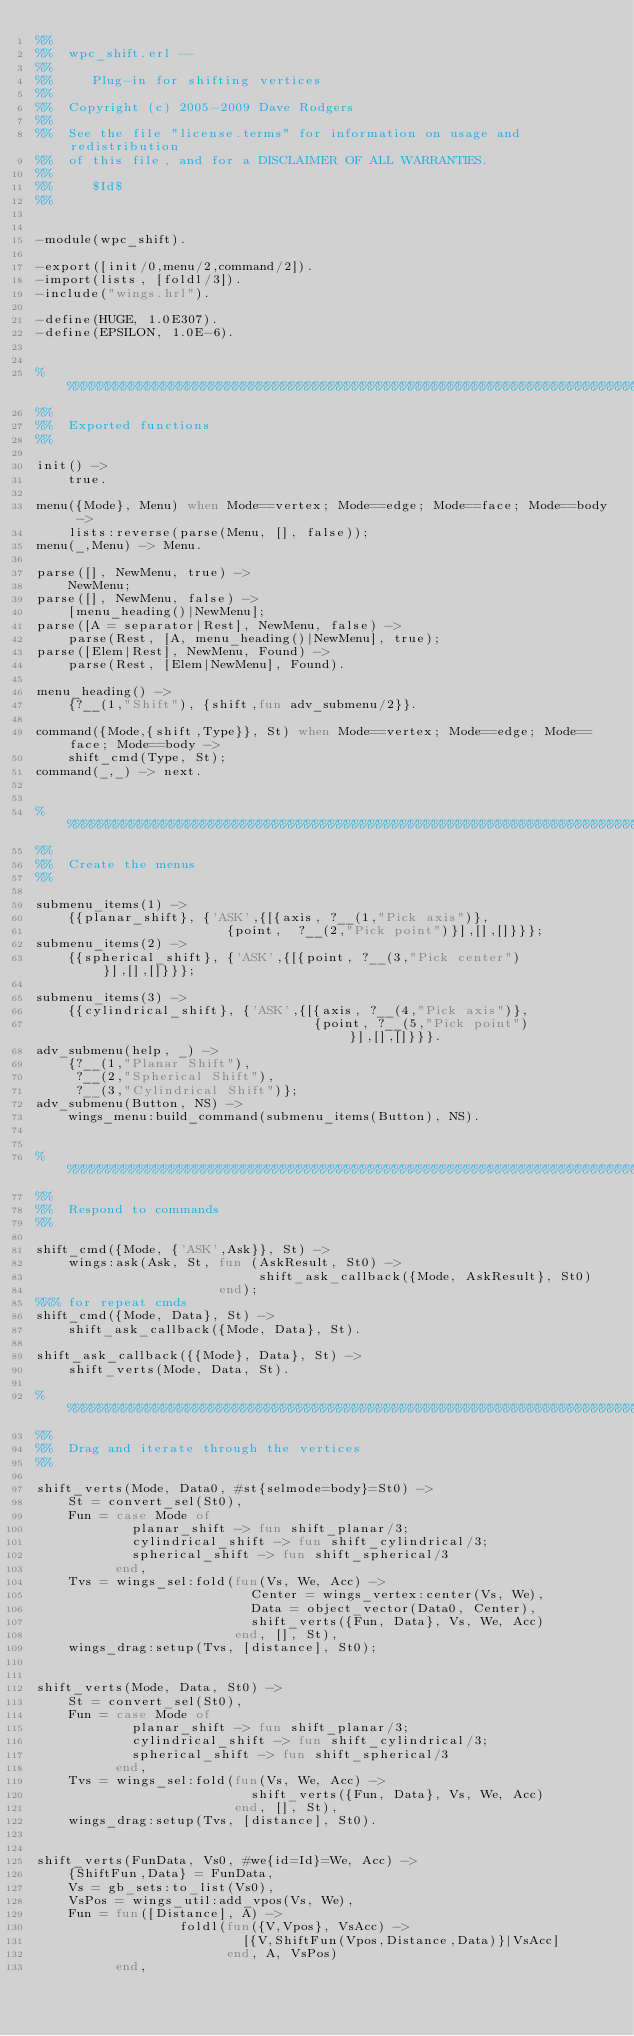Convert code to text. <code><loc_0><loc_0><loc_500><loc_500><_Erlang_>%%
%%  wpc_shift.erl --
%%
%%     Plug-in for shifting vertices
%%
%%  Copyright (c) 2005-2009 Dave Rodgers
%%
%%  See the file "license.terms" for information on usage and redistribution
%%  of this file, and for a DISCLAIMER OF ALL WARRANTIES.
%%
%%     $Id$
%%


-module(wpc_shift).

-export([init/0,menu/2,command/2]).
-import(lists, [foldl/3]).
-include("wings.hrl").

-define(HUGE, 1.0E307).
-define(EPSILON, 1.0E-6).


%%%%%%%%%%%%%%%%%%%%%%%%%%%%%%%%%%%%%%%%%%%%%%%%%%%%%%%%%%%%%%%%%%%%%%%%%%%%%%%%%
%%
%%  Exported functions
%%

init() ->
    true.

menu({Mode}, Menu) when Mode==vertex; Mode==edge; Mode==face; Mode==body ->
    lists:reverse(parse(Menu, [], false));
menu(_,Menu) -> Menu.

parse([], NewMenu, true) ->
    NewMenu;
parse([], NewMenu, false) ->
    [menu_heading()|NewMenu];
parse([A = separator|Rest], NewMenu, false) ->
    parse(Rest, [A, menu_heading()|NewMenu], true);
parse([Elem|Rest], NewMenu, Found) ->
    parse(Rest, [Elem|NewMenu], Found).

menu_heading() ->
    {?__(1,"Shift"), {shift,fun adv_submenu/2}}.

command({Mode,{shift,Type}}, St) when Mode==vertex; Mode==edge; Mode==face; Mode==body ->
    shift_cmd(Type, St);
command(_,_) -> next.


%%%%%%%%%%%%%%%%%%%%%%%%%%%%%%%%%%%%%%%%%%%%%%%%%%%%%%%%%%%%%%%%%%%%%%%%%%%%%%%%%
%%
%%  Create the menus
%%

submenu_items(1) ->
    {{planar_shift}, {'ASK',{[{axis, ?__(1,"Pick axis")},
	                      {point,  ?__(2,"Pick point")}],[],[]}}};
submenu_items(2) ->
    {{spherical_shift}, {'ASK',{[{point, ?__(3,"Pick center")}],[],[]}}};

submenu_items(3) ->
    {{cylindrical_shift}, {'ASK',{[{axis, ?__(4,"Pick axis")},
                                   {point, ?__(5,"Pick point")}],[],[]}}}.
adv_submenu(help, _) ->
    {?__(1,"Planar Shift"),
     ?__(2,"Spherical Shift"),
     ?__(3,"Cylindrical Shift")};
adv_submenu(Button, NS) ->
    wings_menu:build_command(submenu_items(Button), NS).


%%%%%%%%%%%%%%%%%%%%%%%%%%%%%%%%%%%%%%%%%%%%%%%%%%%%%%%%%%%%%%%%%%%%%%%%%%%%%%%%%
%%
%%  Respond to commands
%%

shift_cmd({Mode, {'ASK',Ask}}, St) ->
    wings:ask(Ask, St, fun (AskResult, St0) ->
                            shift_ask_callback({Mode, AskResult}, St0)
                       end);
%%% for repeat cmds
shift_cmd({Mode, Data}, St) ->
    shift_ask_callback({Mode, Data}, St).

shift_ask_callback({{Mode}, Data}, St) ->
    shift_verts(Mode, Data, St).

%%%%%%%%%%%%%%%%%%%%%%%%%%%%%%%%%%%%%%%%%%%%%%%%%%%%%%%%%%%%%%%%%%%%%%%%%%%%%%%%%
%%
%%  Drag and iterate through the vertices
%%

shift_verts(Mode, Data0, #st{selmode=body}=St0) ->
    St = convert_sel(St0),
    Fun = case Mode of
            planar_shift -> fun shift_planar/3;
            cylindrical_shift -> fun shift_cylindrical/3;
            spherical_shift -> fun shift_spherical/3
          end,
    Tvs = wings_sel:fold(fun(Vs, We, Acc) ->
                           Center = wings_vertex:center(Vs, We),
                           Data = object_vector(Data0, Center),
                           shift_verts({Fun, Data}, Vs, We, Acc)
                         end, [], St),
    wings_drag:setup(Tvs, [distance], St0);


shift_verts(Mode, Data, St0) ->
    St = convert_sel(St0),
    Fun = case Mode of
            planar_shift -> fun shift_planar/3;
            cylindrical_shift -> fun shift_cylindrical/3;
            spherical_shift -> fun shift_spherical/3
          end,
    Tvs = wings_sel:fold(fun(Vs, We, Acc) ->
                           shift_verts({Fun, Data}, Vs, We, Acc)
                         end, [], St),
    wings_drag:setup(Tvs, [distance], St0).


shift_verts(FunData, Vs0, #we{id=Id}=We, Acc) ->
    {ShiftFun,Data} = FunData,
    Vs = gb_sets:to_list(Vs0),
    VsPos = wings_util:add_vpos(Vs, We),
    Fun = fun([Distance], A) ->
                  foldl(fun({V,Vpos}, VsAcc) ->
                          [{V,ShiftFun(Vpos,Distance,Data)}|VsAcc]
                        end, A, VsPos)
          end,</code> 